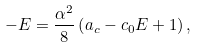Convert formula to latex. <formula><loc_0><loc_0><loc_500><loc_500>- E = \frac { \alpha ^ { 2 } } { 8 } \left ( a _ { c } - c _ { 0 } E + 1 \right ) ,</formula> 